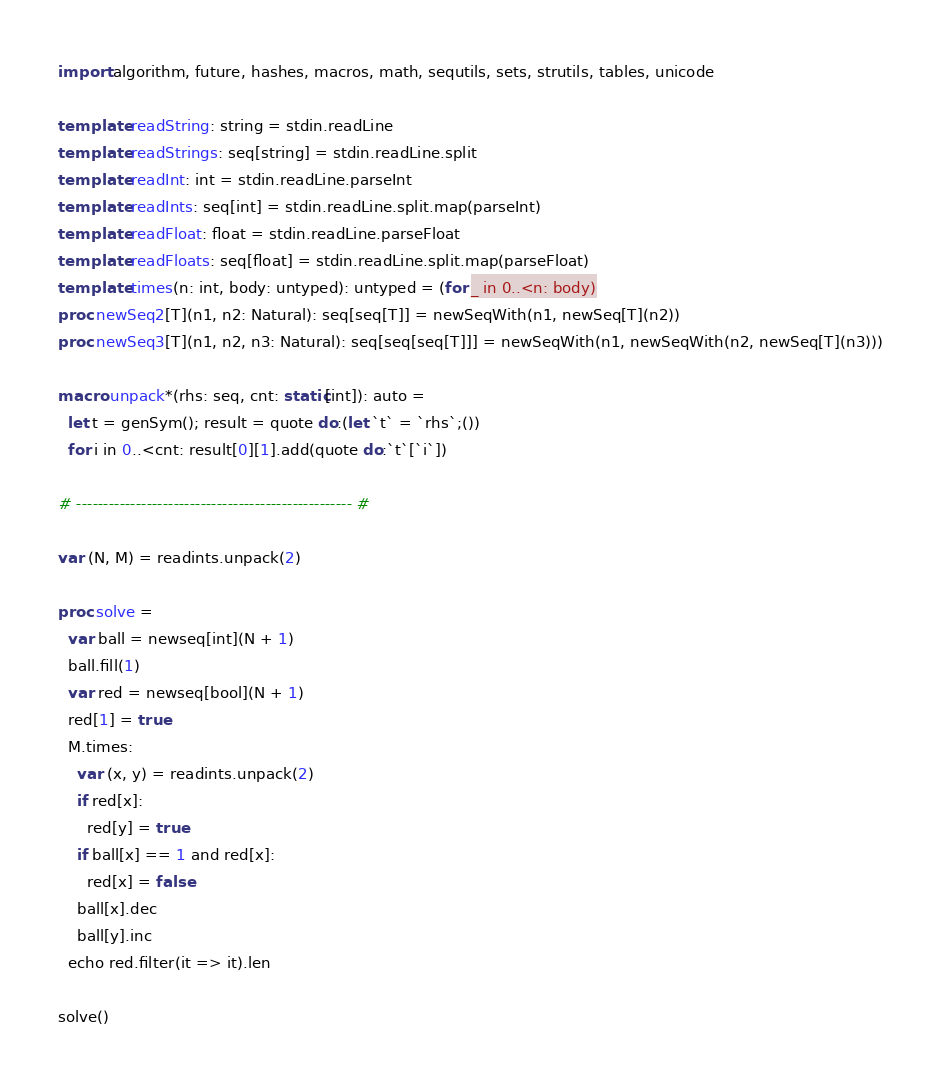Convert code to text. <code><loc_0><loc_0><loc_500><loc_500><_Nim_>import algorithm, future, hashes, macros, math, sequtils, sets, strutils, tables, unicode

template readString: string = stdin.readLine
template readStrings: seq[string] = stdin.readLine.split
template readInt: int = stdin.readLine.parseInt
template readInts: seq[int] = stdin.readLine.split.map(parseInt)
template readFloat: float = stdin.readLine.parseFloat
template readFloats: seq[float] = stdin.readLine.split.map(parseFloat)
template times(n: int, body: untyped): untyped = (for _ in 0..<n: body)
proc newSeq2[T](n1, n2: Natural): seq[seq[T]] = newSeqWith(n1, newSeq[T](n2))
proc newSeq3[T](n1, n2, n3: Natural): seq[seq[seq[T]]] = newSeqWith(n1, newSeqWith(n2, newSeq[T](n3)))

macro unpack*(rhs: seq, cnt: static[int]): auto =
  let t = genSym(); result = quote do:(let `t` = `rhs`;())
  for i in 0..<cnt: result[0][1].add(quote do:`t`[`i`])

# --------------------------------------------------- #

var (N, M) = readints.unpack(2)

proc solve =
  var ball = newseq[int](N + 1)
  ball.fill(1)
  var red = newseq[bool](N + 1)
  red[1] = true
  M.times:
    var (x, y) = readints.unpack(2)
    if red[x]:
      red[y] = true
    if ball[x] == 1 and red[x]:
      red[x] = false
    ball[x].dec
    ball[y].inc
  echo red.filter(it => it).len

solve()</code> 